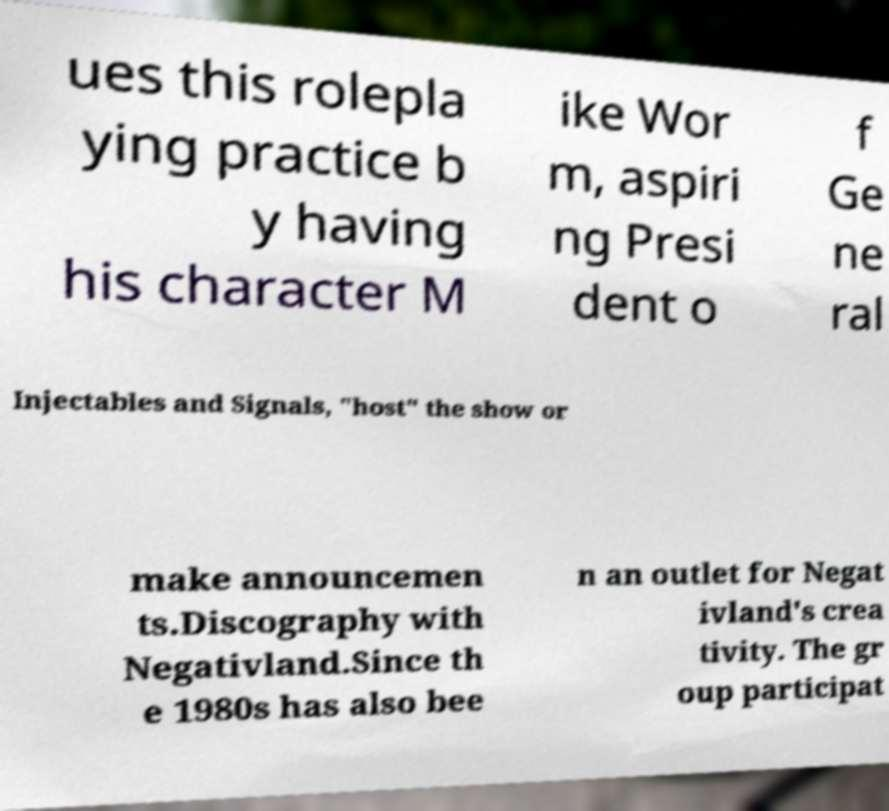What messages or text are displayed in this image? I need them in a readable, typed format. ues this rolepla ying practice b y having his character M ike Wor m, aspiri ng Presi dent o f Ge ne ral Injectables and Signals, "host" the show or make announcemen ts.Discography with Negativland.Since th e 1980s has also bee n an outlet for Negat ivland's crea tivity. The gr oup participat 